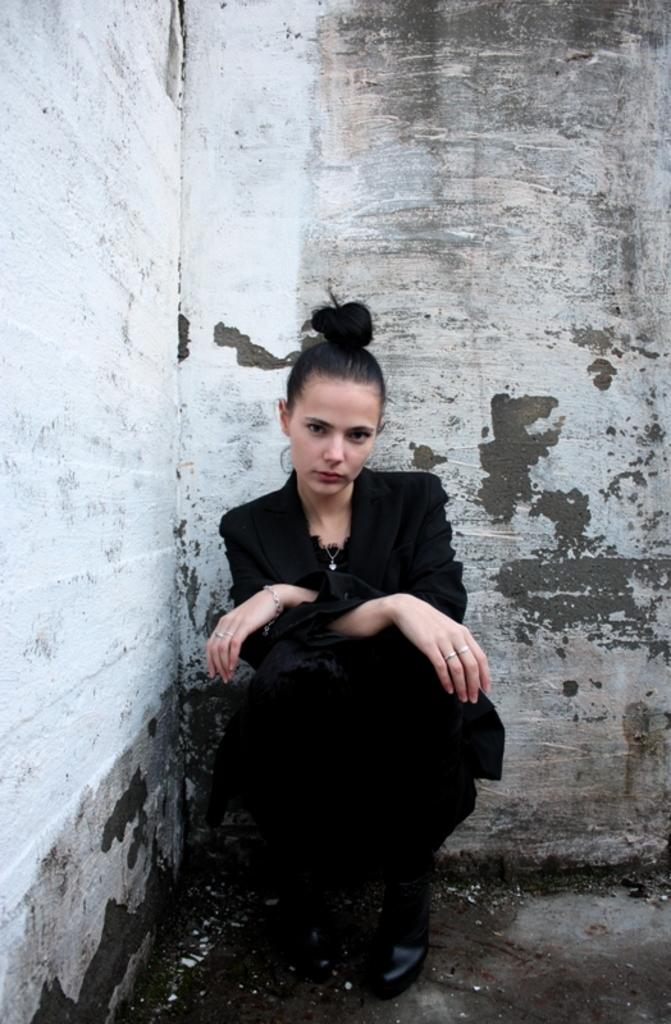Who is the main subject in the image? There is a woman in the image. What is the woman doing in the image? The woman is sitting. What is behind the woman in the image? The woman is in front of a wall. What color is the dress the woman is wearing? The woman is wearing a black dress. What type of kite is the woman flying in the image? There is no kite present in the image; the woman is sitting in front of a wall. 